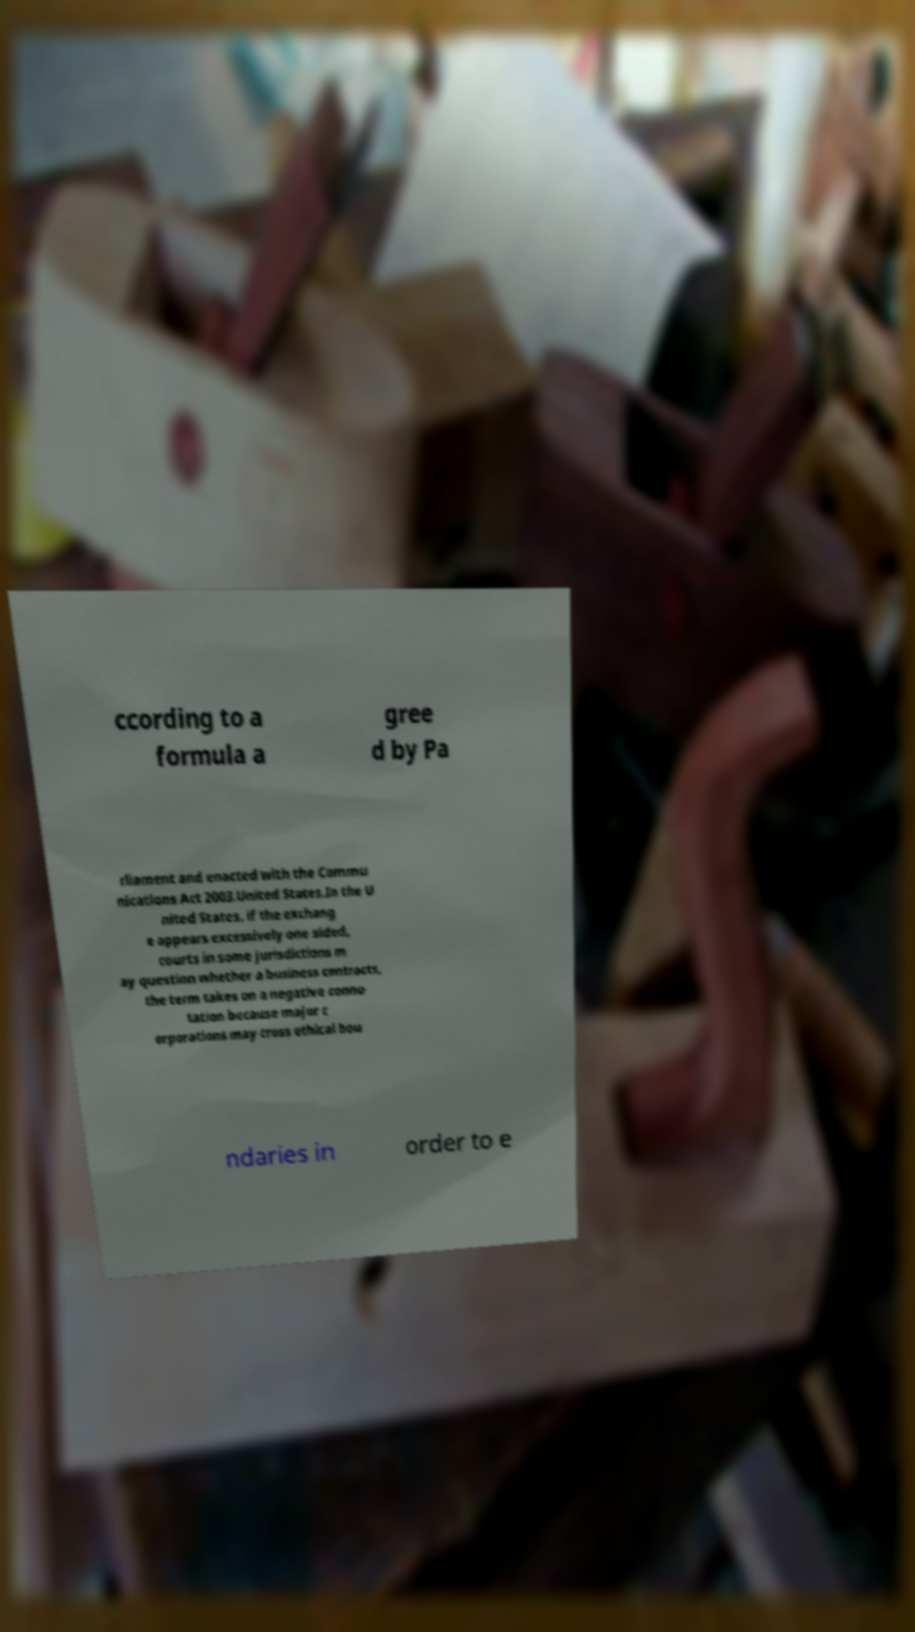What messages or text are displayed in this image? I need them in a readable, typed format. ccording to a formula a gree d by Pa rliament and enacted with the Commu nications Act 2003.United States.In the U nited States, if the exchang e appears excessively one sided, courts in some jurisdictions m ay question whether a business contracts, the term takes on a negative conno tation because major c orporations may cross ethical bou ndaries in order to e 